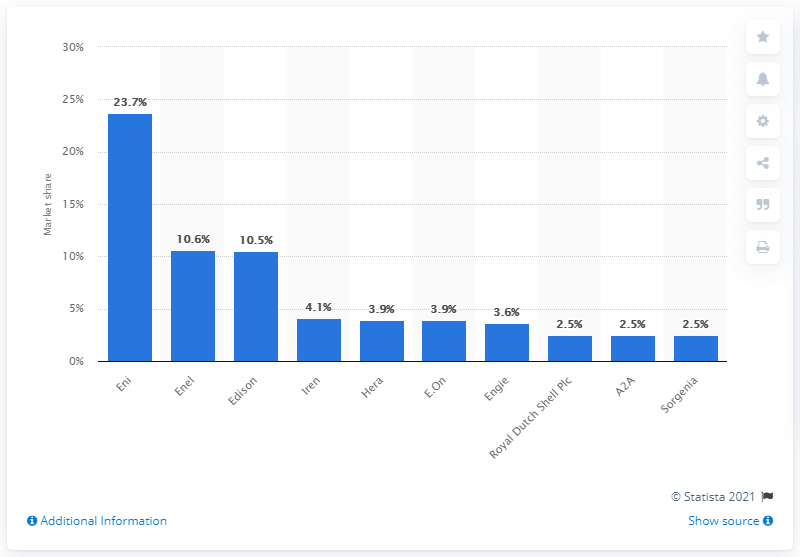Indicate a few pertinent items in this graphic. Enel had the lowest market share in Italy in 2015 among all companies. In 2015, Edison was the company with the lowest market share in Italy. 